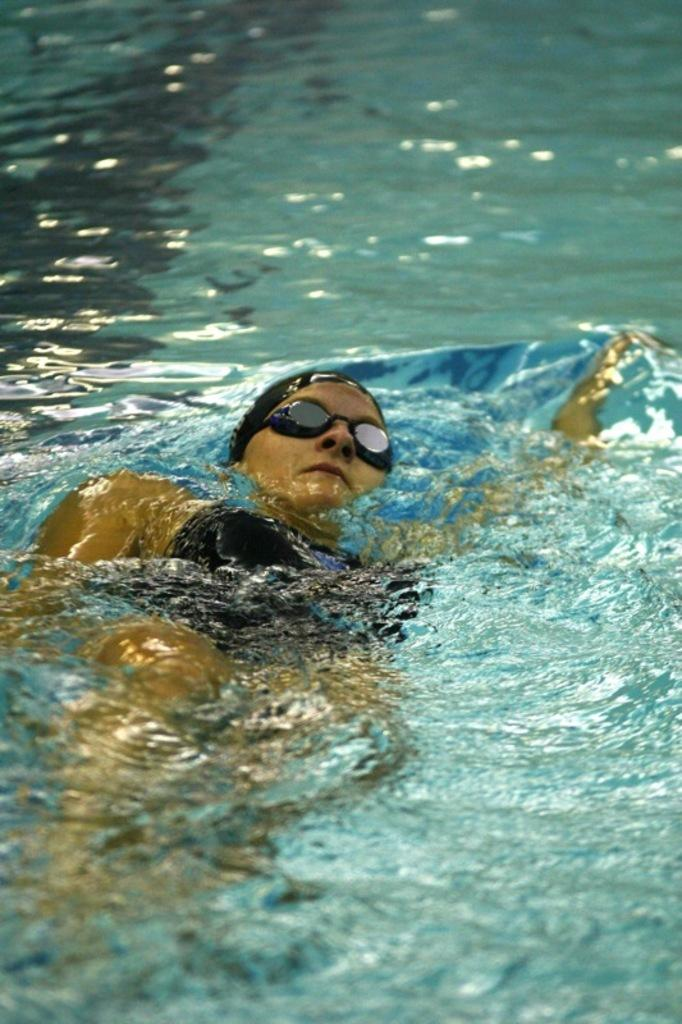Who is the main subject in the image? There is a woman in the image. What is the woman doing in the image? The woman is swimming. What is the woman wearing in the image? The woman is wearing a black dress and black glasses. What is the environment in which the woman is swimming? There is water visible in the image. What invention can be seen in the woman's hand while she is swimming? There is no invention visible in the woman's hand while she is swimming; she is not holding anything. 